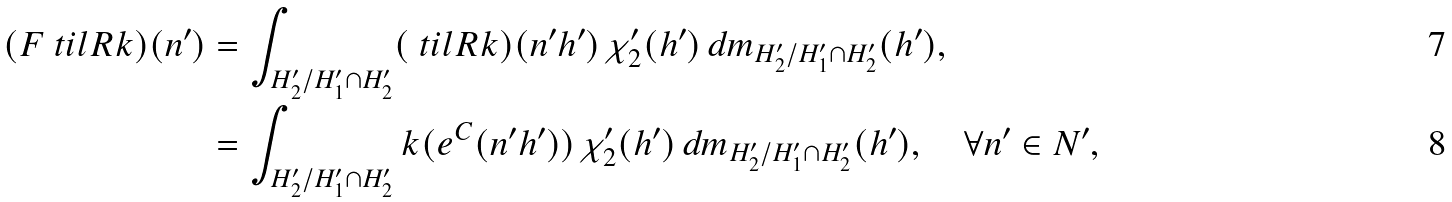<formula> <loc_0><loc_0><loc_500><loc_500>( { F } \ t i l { R } k ) ( n ^ { \prime } ) & = \int _ { H _ { 2 } ^ { \prime } / H _ { 1 } ^ { \prime } \cap H _ { 2 } ^ { \prime } } ( \ t i l { R } k ) ( n ^ { \prime } h ^ { \prime } ) \, \chi _ { 2 } ^ { \prime } ( h ^ { \prime } ) \, d m _ { H _ { 2 } ^ { \prime } / H _ { 1 } ^ { \prime } \cap H _ { 2 } ^ { \prime } } ( h ^ { \prime } ) , \\ & = \int _ { H _ { 2 } ^ { \prime } / H _ { 1 } ^ { \prime } \cap H _ { 2 } ^ { \prime } } k ( e ^ { C } ( n ^ { \prime } h ^ { \prime } ) ) \, \chi _ { 2 } ^ { \prime } ( h ^ { \prime } ) \, d m _ { H _ { 2 } ^ { \prime } / H _ { 1 } ^ { \prime } \cap H _ { 2 } ^ { \prime } } ( h ^ { \prime } ) , \quad \forall n ^ { \prime } \in N ^ { \prime } ,</formula> 